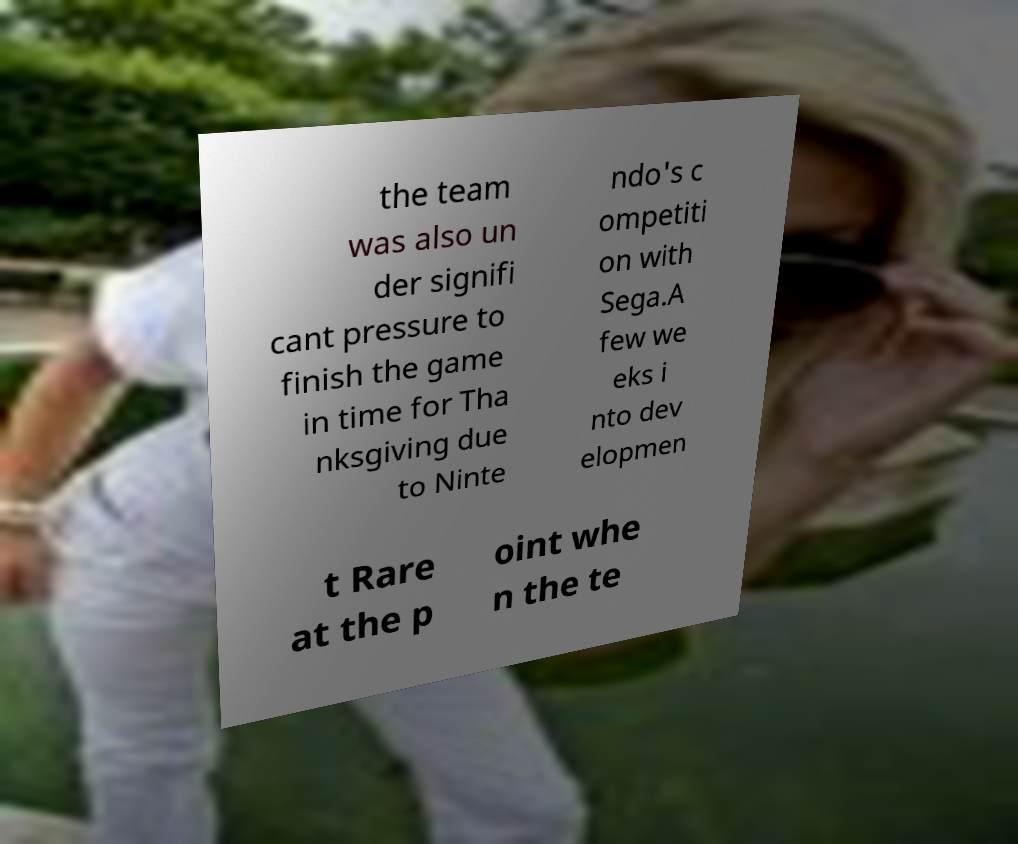For documentation purposes, I need the text within this image transcribed. Could you provide that? the team was also un der signifi cant pressure to finish the game in time for Tha nksgiving due to Ninte ndo's c ompetiti on with Sega.A few we eks i nto dev elopmen t Rare at the p oint whe n the te 